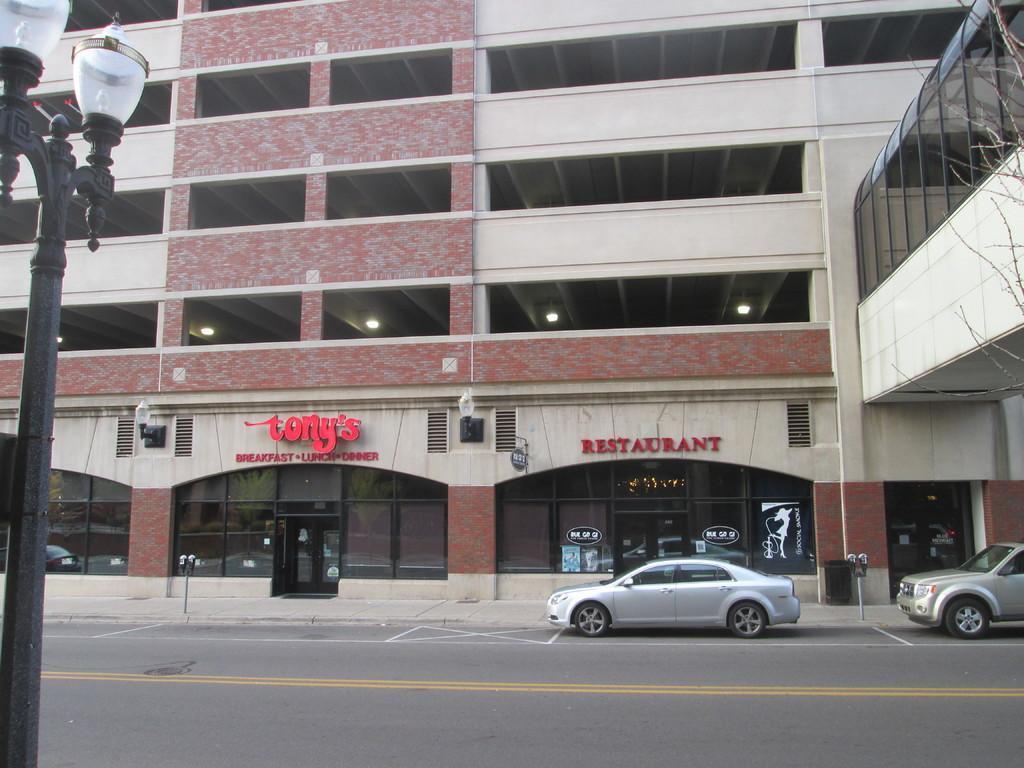Please provide a concise description of this image. In this image we can see a streetlight on the left side of the image and there are few vehicles on the road and we can see a building and there is some text on the building and we can see a bridge on the right side of the image. 